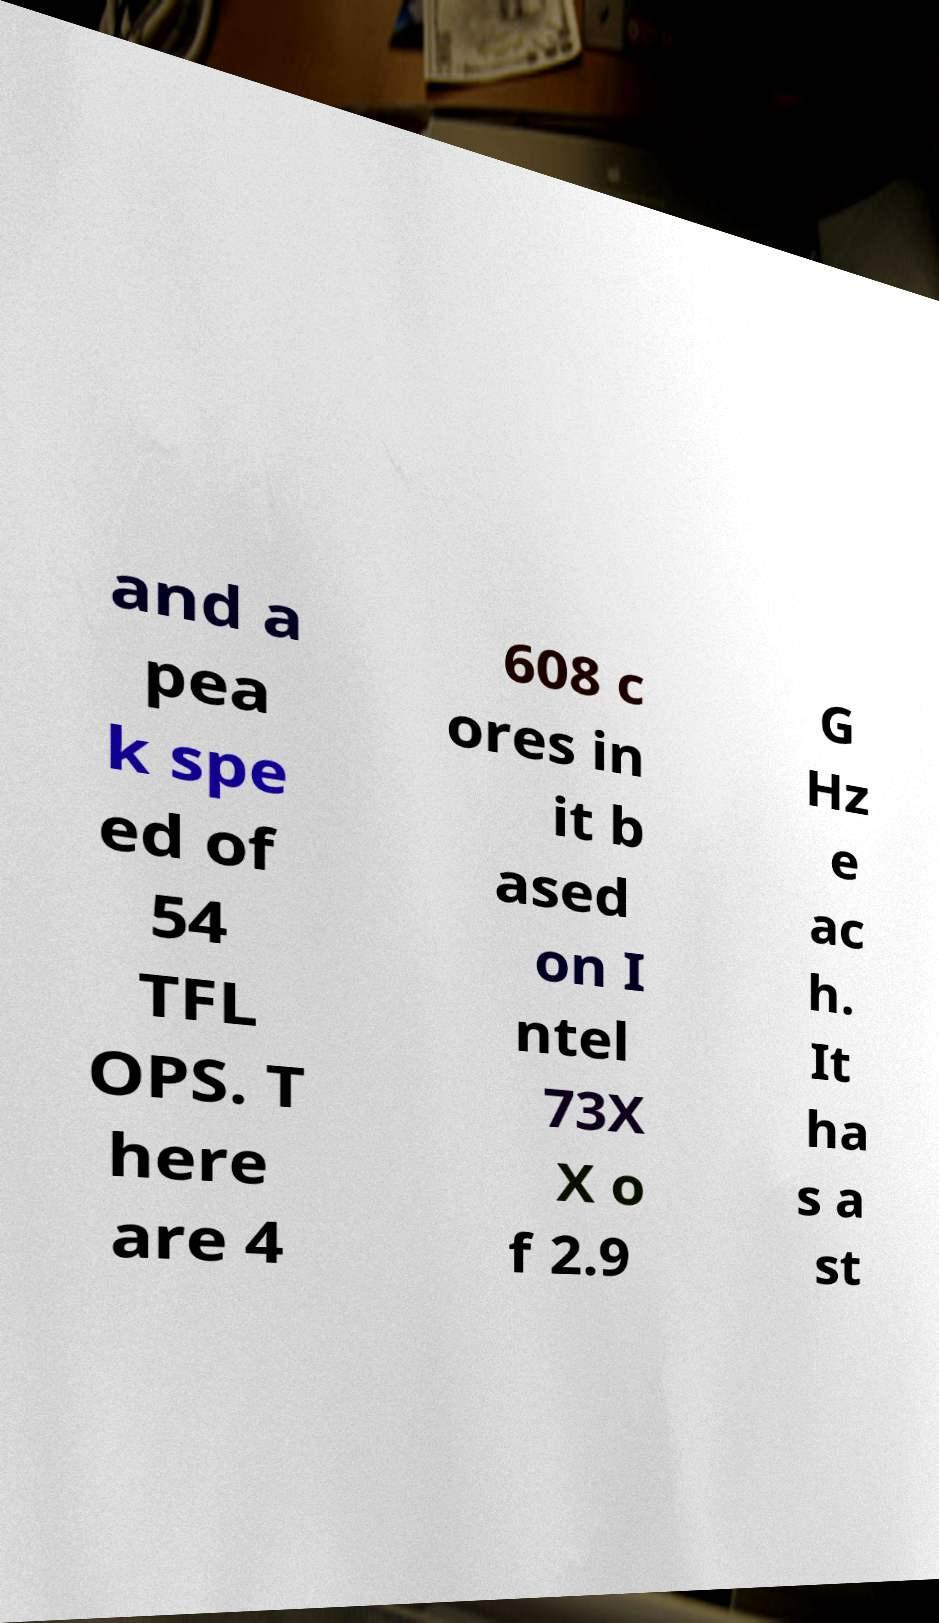For documentation purposes, I need the text within this image transcribed. Could you provide that? and a pea k spe ed of 54 TFL OPS. T here are 4 608 c ores in it b ased on I ntel 73X X o f 2.9 G Hz e ac h. It ha s a st 